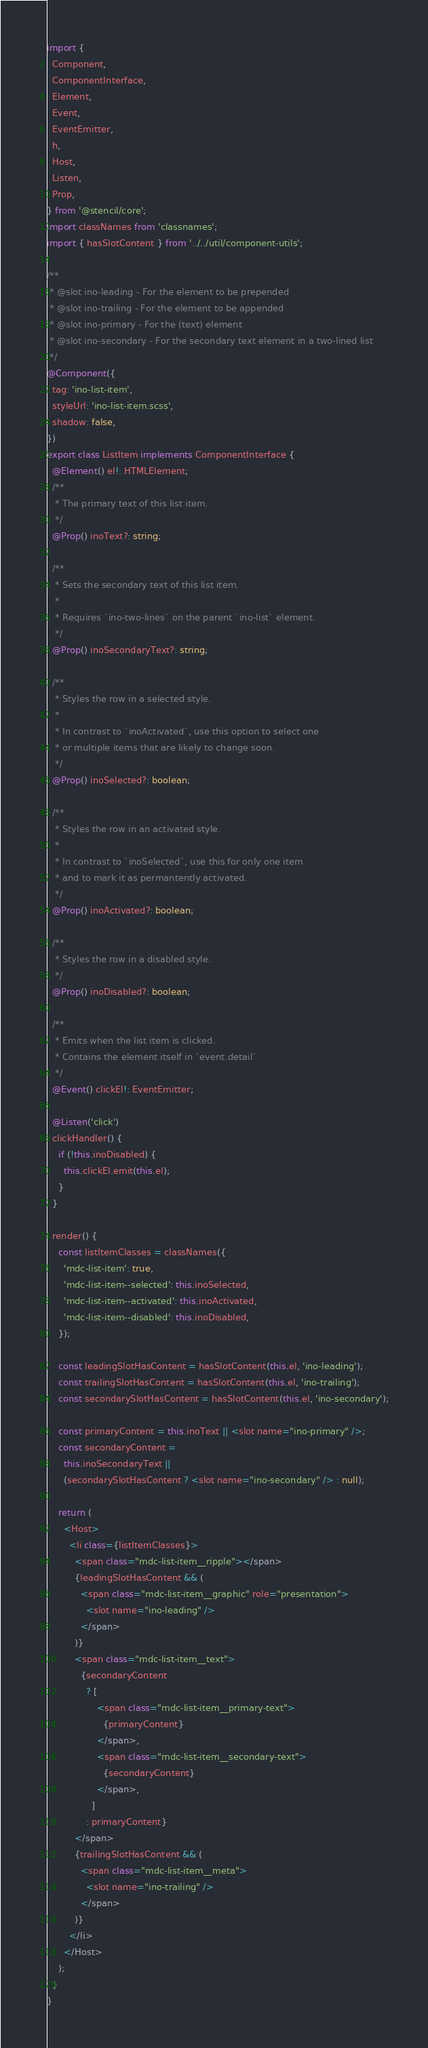Convert code to text. <code><loc_0><loc_0><loc_500><loc_500><_TypeScript_>import {
  Component,
  ComponentInterface,
  Element,
  Event,
  EventEmitter,
  h,
  Host,
  Listen,
  Prop,
} from '@stencil/core';
import classNames from 'classnames';
import { hasSlotContent } from '../../util/component-utils';

/**
 * @slot ino-leading - For the element to be prepended
 * @slot ino-trailing - For the element to be appended
 * @slot ino-primary - For the (text) element
 * @slot ino-secondary - For the secondary text element in a two-lined list
 */
@Component({
  tag: 'ino-list-item',
  styleUrl: 'ino-list-item.scss',
  shadow: false,
})
export class ListItem implements ComponentInterface {
  @Element() el!: HTMLElement;
  /**
   * The primary text of this list item.
   */
  @Prop() inoText?: string;

  /**
   * Sets the secondary text of this list item.
   *
   * Requires `ino-two-lines` on the parent `ino-list` element.
   */
  @Prop() inoSecondaryText?: string;

  /**
   * Styles the row in a selected style.
   *
   * In contrast to `inoActivated`, use this option to select one
   * or multiple items that are likely to change soon.
   */
  @Prop() inoSelected?: boolean;

  /**
   * Styles the row in an activated style.
   *
   * In contrast to `inoSelected`, use this for only one item
   * and to mark it as permantently activated.
   */
  @Prop() inoActivated?: boolean;

  /**
   * Styles the row in a disabled style.
   */
  @Prop() inoDisabled?: boolean;

  /**
   * Emits when the list item is clicked.
   * Contains the element itself in `event.detail`
   */
  @Event() clickEl!: EventEmitter;

  @Listen('click')
  clickHandler() {
    if (!this.inoDisabled) {
      this.clickEl.emit(this.el);
    }
  }

  render() {
    const listItemClasses = classNames({
      'mdc-list-item': true,
      'mdc-list-item--selected': this.inoSelected,
      'mdc-list-item--activated': this.inoActivated,
      'mdc-list-item--disabled': this.inoDisabled,
    });

    const leadingSlotHasContent = hasSlotContent(this.el, 'ino-leading');
    const trailingSlotHasContent = hasSlotContent(this.el, 'ino-trailing');
    const secondarySlotHasContent = hasSlotContent(this.el, 'ino-secondary');

    const primaryContent = this.inoText || <slot name="ino-primary" />;
    const secondaryContent =
      this.inoSecondaryText ||
      (secondarySlotHasContent ? <slot name="ino-secondary" /> : null);

    return (
      <Host>
        <li class={listItemClasses}>
          <span class="mdc-list-item__ripple"></span>
          {leadingSlotHasContent && (
            <span class="mdc-list-item__graphic" role="presentation">
              <slot name="ino-leading" />
            </span>
          )}
          <span class="mdc-list-item__text">
            {secondaryContent
              ? [
                  <span class="mdc-list-item__primary-text">
                    {primaryContent}
                  </span>,
                  <span class="mdc-list-item__secondary-text">
                    {secondaryContent}
                  </span>,
                ]
              : primaryContent}
          </span>
          {trailingSlotHasContent && (
            <span class="mdc-list-item__meta">
              <slot name="ino-trailing" />
            </span>
          )}
        </li>
      </Host>
    );
  }
}
</code> 